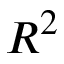<formula> <loc_0><loc_0><loc_500><loc_500>R ^ { 2 }</formula> 